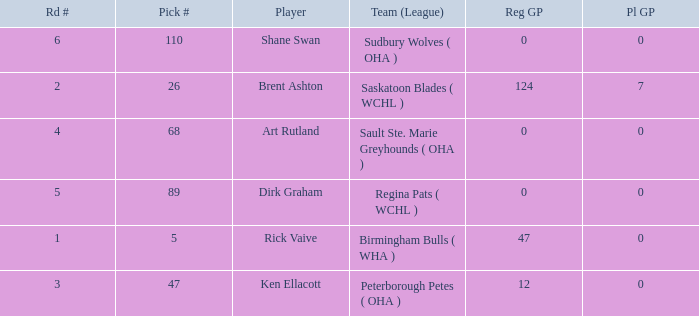How many reg GP for rick vaive in round 1? None. 